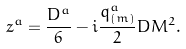<formula> <loc_0><loc_0><loc_500><loc_500>z ^ { a } = { \frac { D ^ { a } } { 6 } } - i { \frac { q _ { ( m ) } ^ { a } } { 2 } } D M ^ { 2 } .</formula> 